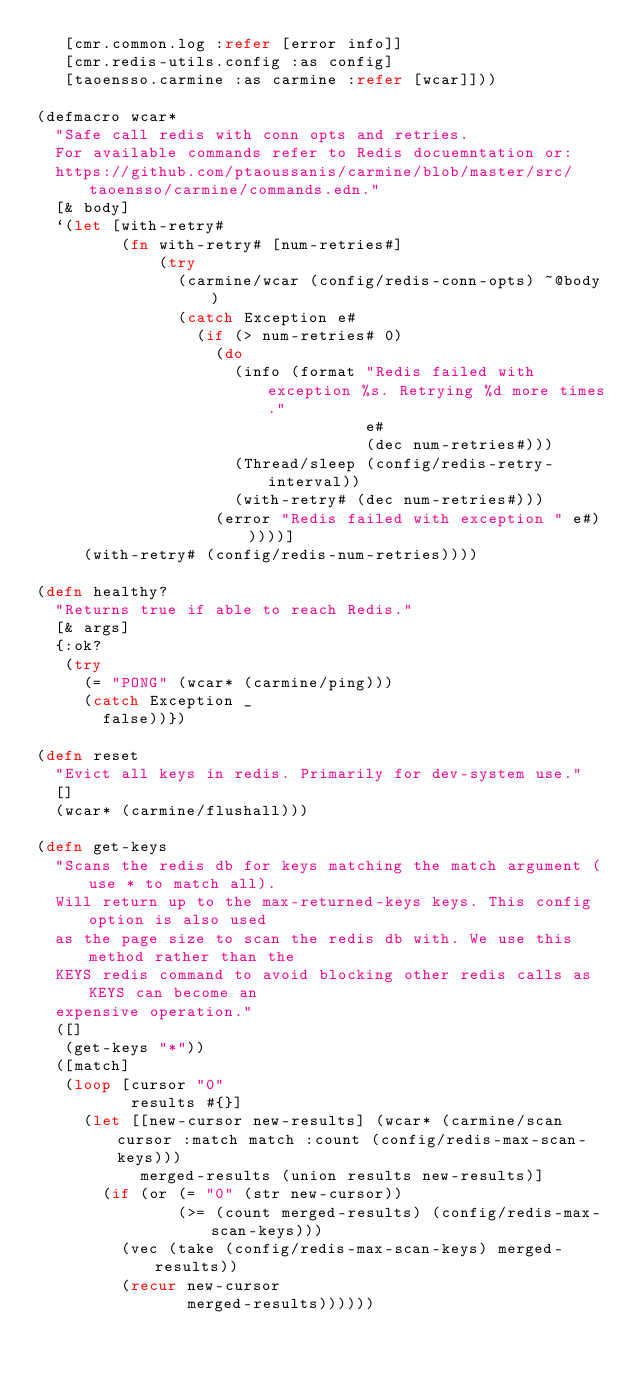<code> <loc_0><loc_0><loc_500><loc_500><_Clojure_>   [cmr.common.log :refer [error info]]
   [cmr.redis-utils.config :as config]
   [taoensso.carmine :as carmine :refer [wcar]]))

(defmacro wcar*
  "Safe call redis with conn opts and retries.
  For available commands refer to Redis docuemntation or:
  https://github.com/ptaoussanis/carmine/blob/master/src/taoensso/carmine/commands.edn."
  [& body]
  `(let [with-retry#
         (fn with-retry# [num-retries#]
             (try
               (carmine/wcar (config/redis-conn-opts) ~@body)
               (catch Exception e#
                 (if (> num-retries# 0)
                   (do
                     (info (format "Redis failed with exception %s. Retrying %d more times."
                                   e#
                                   (dec num-retries#)))
                     (Thread/sleep (config/redis-retry-interval))
                     (with-retry# (dec num-retries#)))
                   (error "Redis failed with exception " e#)))))]
     (with-retry# (config/redis-num-retries))))

(defn healthy?
  "Returns true if able to reach Redis."
  [& args]
  {:ok?
   (try
     (= "PONG" (wcar* (carmine/ping)))
     (catch Exception _
       false))})

(defn reset
  "Evict all keys in redis. Primarily for dev-system use."
  []
  (wcar* (carmine/flushall)))

(defn get-keys
  "Scans the redis db for keys matching the match argument (use * to match all).
  Will return up to the max-returned-keys keys. This config option is also used
  as the page size to scan the redis db with. We use this method rather than the
  KEYS redis command to avoid blocking other redis calls as KEYS can become an
  expensive operation."
  ([]
   (get-keys "*"))
  ([match]
   (loop [cursor "0"
          results #{}]
     (let [[new-cursor new-results] (wcar* (carmine/scan cursor :match match :count (config/redis-max-scan-keys)))
           merged-results (union results new-results)]
       (if (or (= "0" (str new-cursor))
               (>= (count merged-results) (config/redis-max-scan-keys)))
         (vec (take (config/redis-max-scan-keys) merged-results))
         (recur new-cursor
                merged-results))))))
</code> 